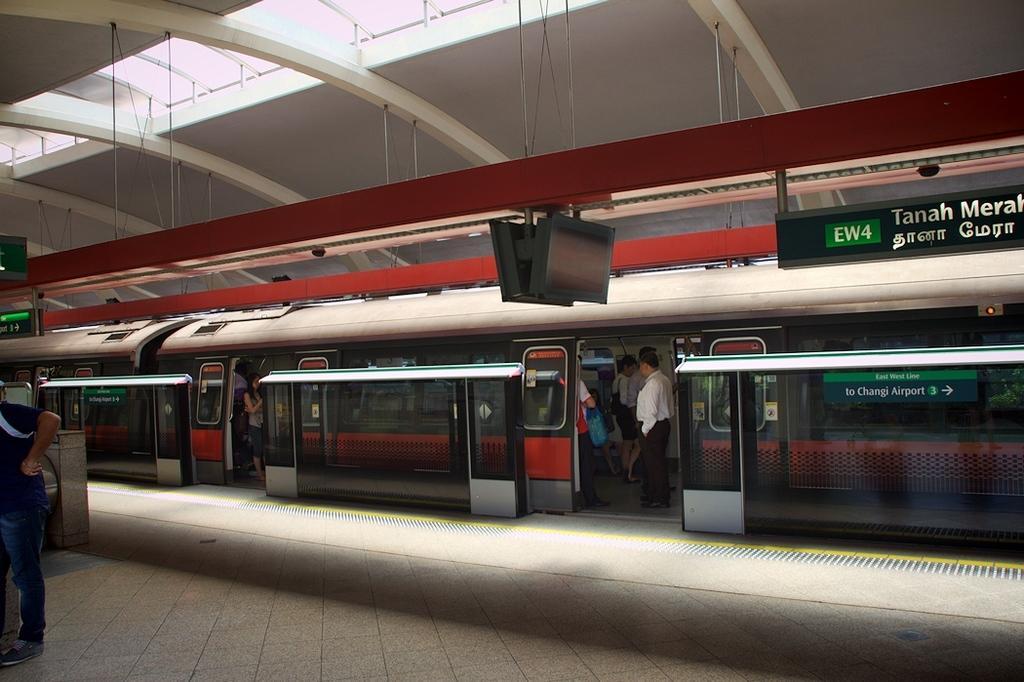In one or two sentences, can you explain what this image depicts? This picture shows a train and we see a platform and a display board and we see a man Standing and we see few people in the train. 